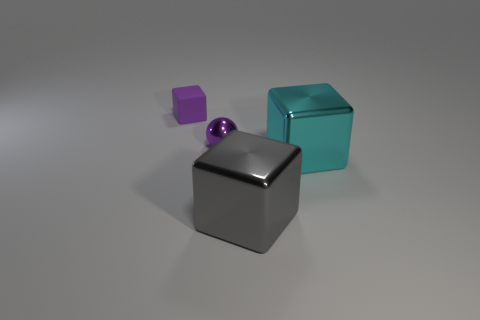Subtract all large gray blocks. How many blocks are left? 2 Add 1 metallic objects. How many objects exist? 5 Subtract 2 blocks. How many blocks are left? 1 Subtract all cyan blocks. How many blocks are left? 2 Subtract all cubes. How many objects are left? 1 Subtract all blue blocks. How many gray balls are left? 0 Subtract all tiny cubes. Subtract all gray shiny cubes. How many objects are left? 2 Add 2 small purple spheres. How many small purple spheres are left? 3 Add 3 shiny balls. How many shiny balls exist? 4 Subtract 0 brown spheres. How many objects are left? 4 